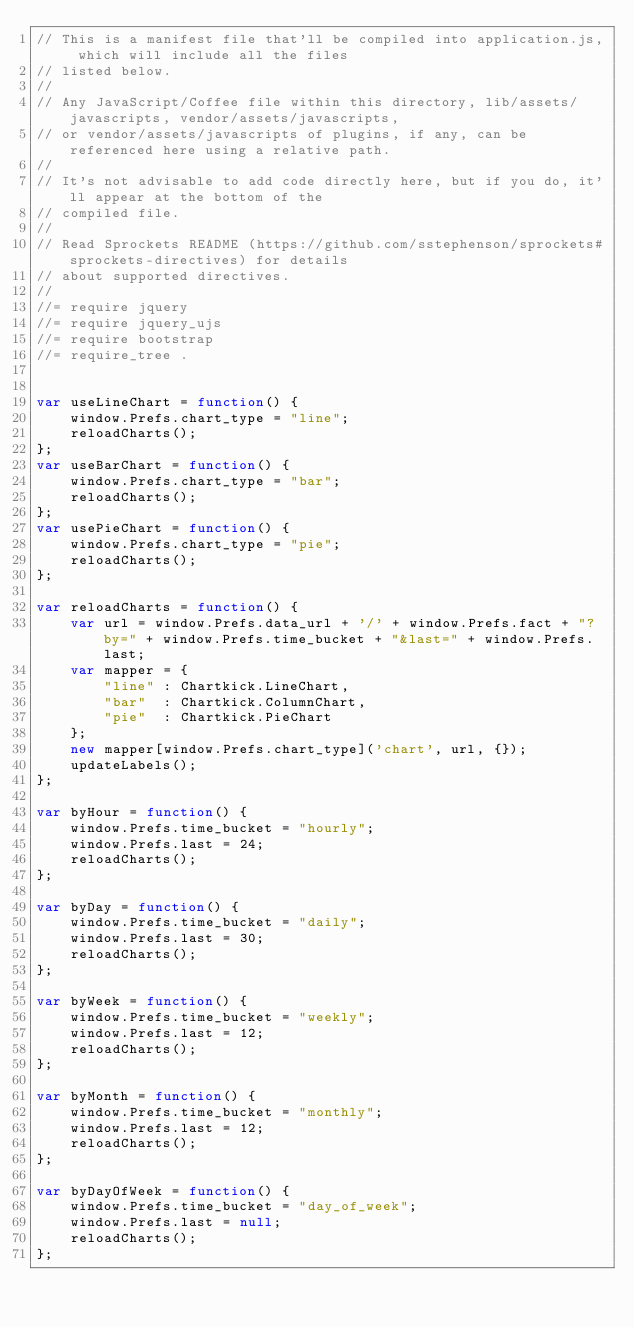<code> <loc_0><loc_0><loc_500><loc_500><_JavaScript_>// This is a manifest file that'll be compiled into application.js, which will include all the files
// listed below.
//
// Any JavaScript/Coffee file within this directory, lib/assets/javascripts, vendor/assets/javascripts,
// or vendor/assets/javascripts of plugins, if any, can be referenced here using a relative path.
//
// It's not advisable to add code directly here, but if you do, it'll appear at the bottom of the
// compiled file.
//
// Read Sprockets README (https://github.com/sstephenson/sprockets#sprockets-directives) for details
// about supported directives.
//
//= require jquery
//= require jquery_ujs
//= require bootstrap
//= require_tree .


var useLineChart = function() {
    window.Prefs.chart_type = "line";
    reloadCharts();
};
var useBarChart = function() {
    window.Prefs.chart_type = "bar";
    reloadCharts();
};
var usePieChart = function() {
    window.Prefs.chart_type = "pie";
    reloadCharts();
};

var reloadCharts = function() {
    var url = window.Prefs.data_url + '/' + window.Prefs.fact + "?by=" + window.Prefs.time_bucket + "&last=" + window.Prefs.last;
    var mapper = {
        "line" : Chartkick.LineChart,
        "bar"  : Chartkick.ColumnChart,
        "pie"  : Chartkick.PieChart
    };
    new mapper[window.Prefs.chart_type]('chart', url, {});
    updateLabels();
};

var byHour = function() {
    window.Prefs.time_bucket = "hourly";
    window.Prefs.last = 24;
    reloadCharts();
};

var byDay = function() {
    window.Prefs.time_bucket = "daily";
    window.Prefs.last = 30;
    reloadCharts();
};

var byWeek = function() {
    window.Prefs.time_bucket = "weekly";
    window.Prefs.last = 12;
    reloadCharts();
};

var byMonth = function() {
    window.Prefs.time_bucket = "monthly";
    window.Prefs.last = 12;
    reloadCharts();
};

var byDayOfWeek = function() {
    window.Prefs.time_bucket = "day_of_week";
    window.Prefs.last = null;
    reloadCharts();
};
</code> 